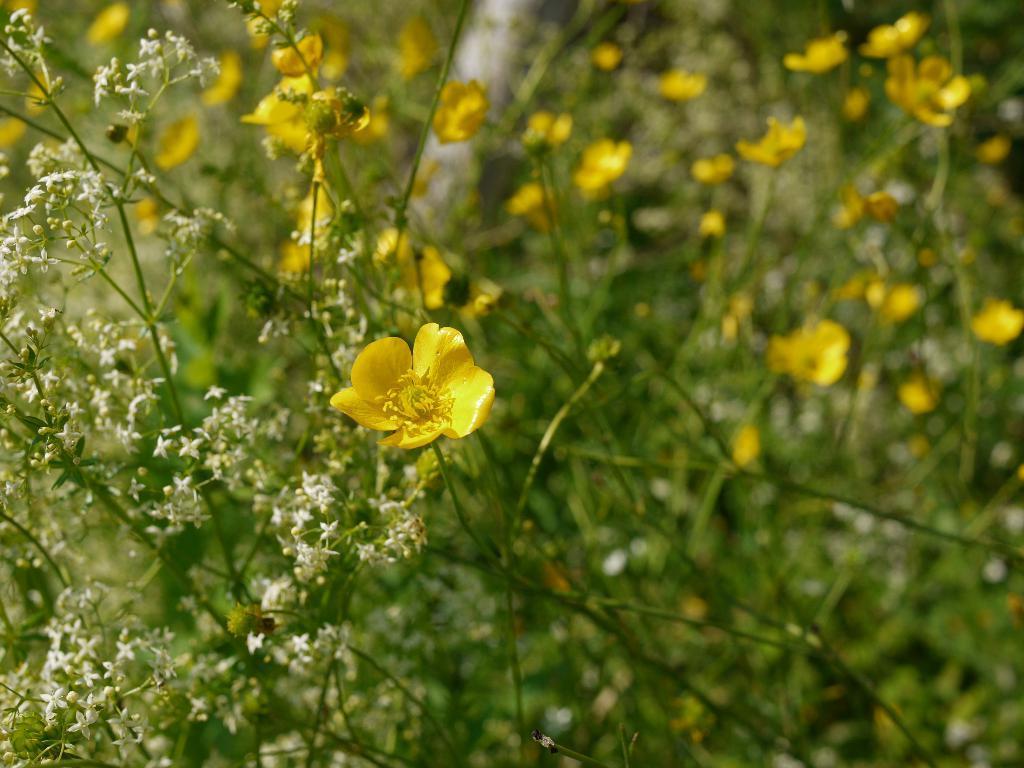How would you summarize this image in a sentence or two? In this picture we can see plants with flowers and in the background it is blurry. 